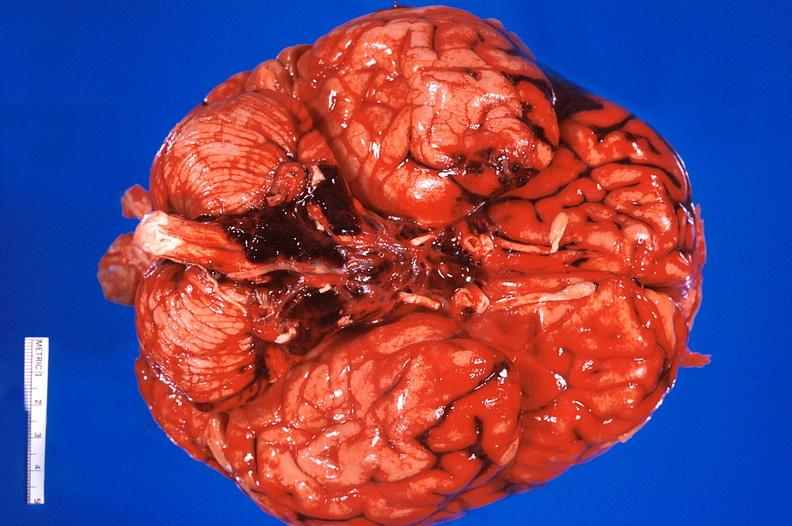does cortical nodule show brain?
Answer the question using a single word or phrase. No 